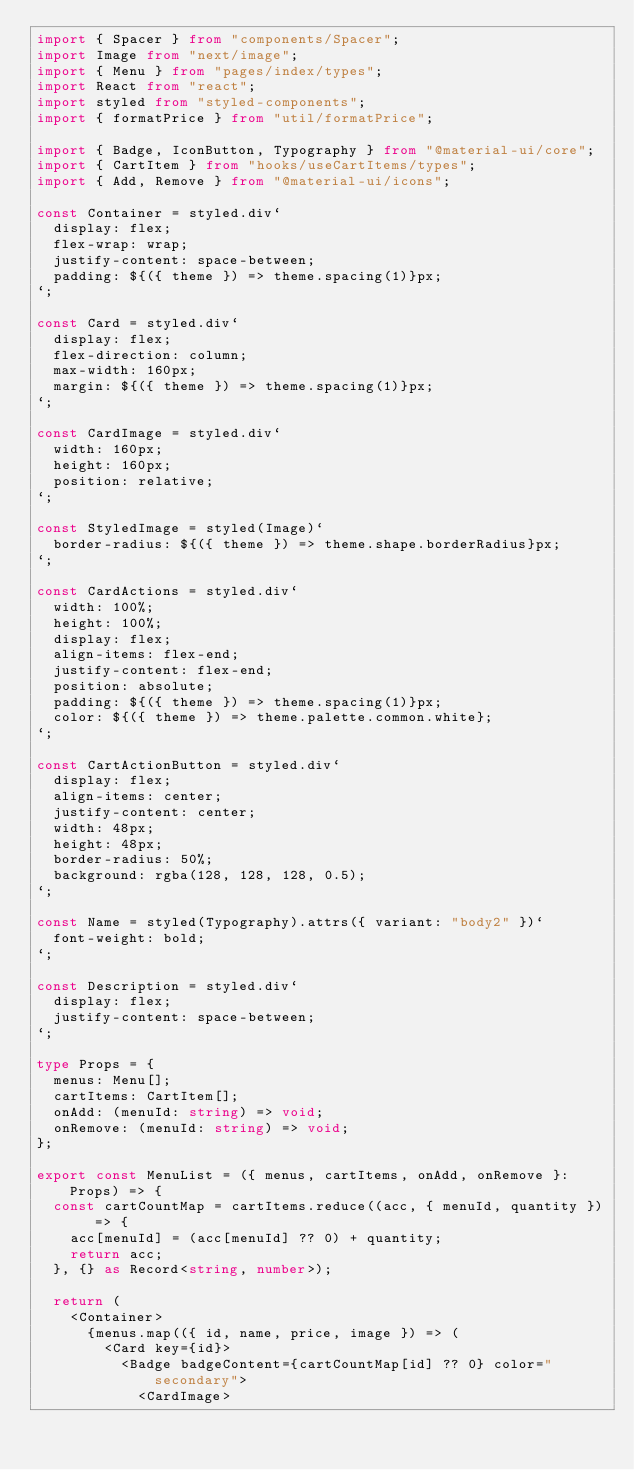<code> <loc_0><loc_0><loc_500><loc_500><_TypeScript_>import { Spacer } from "components/Spacer";
import Image from "next/image";
import { Menu } from "pages/index/types";
import React from "react";
import styled from "styled-components";
import { formatPrice } from "util/formatPrice";

import { Badge, IconButton, Typography } from "@material-ui/core";
import { CartItem } from "hooks/useCartItems/types";
import { Add, Remove } from "@material-ui/icons";

const Container = styled.div`
  display: flex;
  flex-wrap: wrap;
  justify-content: space-between;
  padding: ${({ theme }) => theme.spacing(1)}px;
`;

const Card = styled.div`
  display: flex;
  flex-direction: column;
  max-width: 160px;
  margin: ${({ theme }) => theme.spacing(1)}px;
`;

const CardImage = styled.div`
  width: 160px;
  height: 160px;
  position: relative;
`;

const StyledImage = styled(Image)`
  border-radius: ${({ theme }) => theme.shape.borderRadius}px;
`;

const CardActions = styled.div`
  width: 100%;
  height: 100%;
  display: flex;
  align-items: flex-end;
  justify-content: flex-end;
  position: absolute;
  padding: ${({ theme }) => theme.spacing(1)}px;
  color: ${({ theme }) => theme.palette.common.white};
`;

const CartActionButton = styled.div`
  display: flex;
  align-items: center;
  justify-content: center;
  width: 48px;
  height: 48px;
  border-radius: 50%;
  background: rgba(128, 128, 128, 0.5);
`;

const Name = styled(Typography).attrs({ variant: "body2" })`
  font-weight: bold;
`;

const Description = styled.div`
  display: flex;
  justify-content: space-between;
`;

type Props = {
  menus: Menu[];
  cartItems: CartItem[];
  onAdd: (menuId: string) => void;
  onRemove: (menuId: string) => void;
};

export const MenuList = ({ menus, cartItems, onAdd, onRemove }: Props) => {
  const cartCountMap = cartItems.reduce((acc, { menuId, quantity }) => {
    acc[menuId] = (acc[menuId] ?? 0) + quantity;
    return acc;
  }, {} as Record<string, number>);

  return (
    <Container>
      {menus.map(({ id, name, price, image }) => (
        <Card key={id}>
          <Badge badgeContent={cartCountMap[id] ?? 0} color="secondary">
            <CardImage></code> 